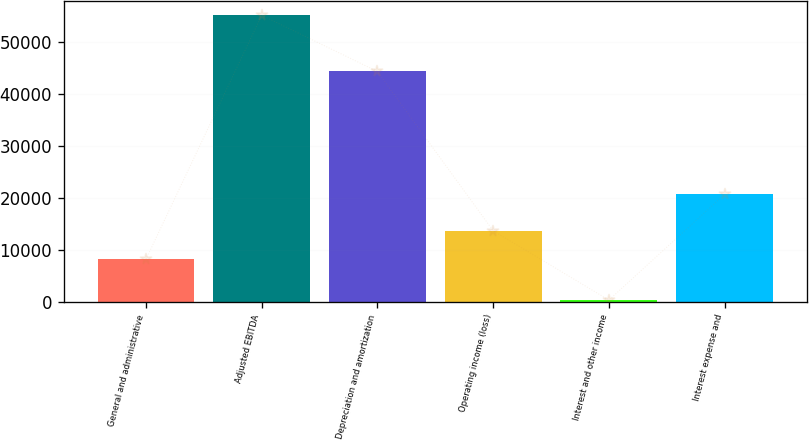Convert chart to OTSL. <chart><loc_0><loc_0><loc_500><loc_500><bar_chart><fcel>General and administrative<fcel>Adjusted EBITDA<fcel>Depreciation and amortization<fcel>Operating income (loss)<fcel>Interest and other income<fcel>Interest expense and<nl><fcel>8169<fcel>55090<fcel>44277<fcel>13647.1<fcel>309<fcel>20651<nl></chart> 